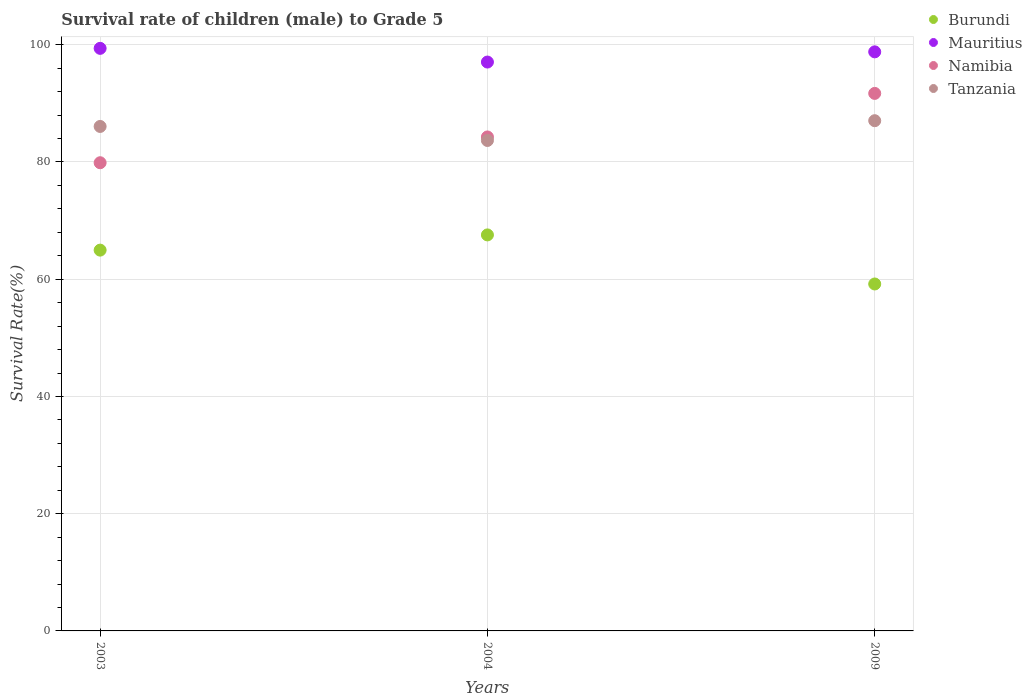How many different coloured dotlines are there?
Offer a terse response. 4. What is the survival rate of male children to grade 5 in Mauritius in 2004?
Provide a succinct answer. 97.05. Across all years, what is the maximum survival rate of male children to grade 5 in Namibia?
Your response must be concise. 91.7. Across all years, what is the minimum survival rate of male children to grade 5 in Mauritius?
Ensure brevity in your answer.  97.05. In which year was the survival rate of male children to grade 5 in Namibia minimum?
Offer a very short reply. 2003. What is the total survival rate of male children to grade 5 in Namibia in the graph?
Offer a very short reply. 255.85. What is the difference between the survival rate of male children to grade 5 in Mauritius in 2003 and that in 2009?
Offer a very short reply. 0.6. What is the difference between the survival rate of male children to grade 5 in Tanzania in 2003 and the survival rate of male children to grade 5 in Namibia in 2009?
Make the answer very short. -5.64. What is the average survival rate of male children to grade 5 in Mauritius per year?
Give a very brief answer. 98.41. In the year 2003, what is the difference between the survival rate of male children to grade 5 in Tanzania and survival rate of male children to grade 5 in Burundi?
Your answer should be very brief. 21.1. In how many years, is the survival rate of male children to grade 5 in Namibia greater than 28 %?
Provide a short and direct response. 3. What is the ratio of the survival rate of male children to grade 5 in Mauritius in 2004 to that in 2009?
Your answer should be compact. 0.98. Is the survival rate of male children to grade 5 in Burundi in 2004 less than that in 2009?
Your answer should be very brief. No. Is the difference between the survival rate of male children to grade 5 in Tanzania in 2003 and 2004 greater than the difference between the survival rate of male children to grade 5 in Burundi in 2003 and 2004?
Keep it short and to the point. Yes. What is the difference between the highest and the second highest survival rate of male children to grade 5 in Burundi?
Offer a terse response. 2.6. What is the difference between the highest and the lowest survival rate of male children to grade 5 in Mauritius?
Ensure brevity in your answer.  2.34. In how many years, is the survival rate of male children to grade 5 in Tanzania greater than the average survival rate of male children to grade 5 in Tanzania taken over all years?
Ensure brevity in your answer.  2. Does the survival rate of male children to grade 5 in Burundi monotonically increase over the years?
Your answer should be compact. No. Is the survival rate of male children to grade 5 in Mauritius strictly greater than the survival rate of male children to grade 5 in Tanzania over the years?
Provide a succinct answer. Yes. How many dotlines are there?
Provide a succinct answer. 4. How many years are there in the graph?
Give a very brief answer. 3. Are the values on the major ticks of Y-axis written in scientific E-notation?
Offer a very short reply. No. How many legend labels are there?
Your response must be concise. 4. What is the title of the graph?
Ensure brevity in your answer.  Survival rate of children (male) to Grade 5. What is the label or title of the Y-axis?
Offer a terse response. Survival Rate(%). What is the Survival Rate(%) in Burundi in 2003?
Provide a succinct answer. 64.96. What is the Survival Rate(%) of Mauritius in 2003?
Offer a very short reply. 99.39. What is the Survival Rate(%) of Namibia in 2003?
Keep it short and to the point. 79.87. What is the Survival Rate(%) in Tanzania in 2003?
Your answer should be very brief. 86.06. What is the Survival Rate(%) of Burundi in 2004?
Provide a succinct answer. 67.56. What is the Survival Rate(%) in Mauritius in 2004?
Your response must be concise. 97.05. What is the Survival Rate(%) of Namibia in 2004?
Ensure brevity in your answer.  84.27. What is the Survival Rate(%) in Tanzania in 2004?
Your answer should be very brief. 83.67. What is the Survival Rate(%) of Burundi in 2009?
Offer a terse response. 59.19. What is the Survival Rate(%) of Mauritius in 2009?
Your response must be concise. 98.79. What is the Survival Rate(%) in Namibia in 2009?
Your response must be concise. 91.7. What is the Survival Rate(%) of Tanzania in 2009?
Offer a terse response. 87.04. Across all years, what is the maximum Survival Rate(%) of Burundi?
Keep it short and to the point. 67.56. Across all years, what is the maximum Survival Rate(%) of Mauritius?
Provide a short and direct response. 99.39. Across all years, what is the maximum Survival Rate(%) in Namibia?
Your answer should be very brief. 91.7. Across all years, what is the maximum Survival Rate(%) in Tanzania?
Provide a succinct answer. 87.04. Across all years, what is the minimum Survival Rate(%) of Burundi?
Your answer should be compact. 59.19. Across all years, what is the minimum Survival Rate(%) of Mauritius?
Keep it short and to the point. 97.05. Across all years, what is the minimum Survival Rate(%) of Namibia?
Give a very brief answer. 79.87. Across all years, what is the minimum Survival Rate(%) of Tanzania?
Keep it short and to the point. 83.67. What is the total Survival Rate(%) of Burundi in the graph?
Offer a very short reply. 191.71. What is the total Survival Rate(%) of Mauritius in the graph?
Keep it short and to the point. 295.23. What is the total Survival Rate(%) in Namibia in the graph?
Your answer should be compact. 255.85. What is the total Survival Rate(%) of Tanzania in the graph?
Give a very brief answer. 256.78. What is the difference between the Survival Rate(%) in Burundi in 2003 and that in 2004?
Make the answer very short. -2.6. What is the difference between the Survival Rate(%) in Mauritius in 2003 and that in 2004?
Keep it short and to the point. 2.34. What is the difference between the Survival Rate(%) in Namibia in 2003 and that in 2004?
Provide a succinct answer. -4.4. What is the difference between the Survival Rate(%) of Tanzania in 2003 and that in 2004?
Give a very brief answer. 2.39. What is the difference between the Survival Rate(%) in Burundi in 2003 and that in 2009?
Your answer should be compact. 5.78. What is the difference between the Survival Rate(%) of Mauritius in 2003 and that in 2009?
Provide a succinct answer. 0.6. What is the difference between the Survival Rate(%) in Namibia in 2003 and that in 2009?
Your answer should be compact. -11.83. What is the difference between the Survival Rate(%) of Tanzania in 2003 and that in 2009?
Your answer should be compact. -0.98. What is the difference between the Survival Rate(%) in Burundi in 2004 and that in 2009?
Provide a succinct answer. 8.37. What is the difference between the Survival Rate(%) in Mauritius in 2004 and that in 2009?
Make the answer very short. -1.74. What is the difference between the Survival Rate(%) of Namibia in 2004 and that in 2009?
Provide a short and direct response. -7.43. What is the difference between the Survival Rate(%) of Tanzania in 2004 and that in 2009?
Provide a short and direct response. -3.37. What is the difference between the Survival Rate(%) in Burundi in 2003 and the Survival Rate(%) in Mauritius in 2004?
Make the answer very short. -32.09. What is the difference between the Survival Rate(%) in Burundi in 2003 and the Survival Rate(%) in Namibia in 2004?
Provide a short and direct response. -19.31. What is the difference between the Survival Rate(%) of Burundi in 2003 and the Survival Rate(%) of Tanzania in 2004?
Provide a short and direct response. -18.71. What is the difference between the Survival Rate(%) of Mauritius in 2003 and the Survival Rate(%) of Namibia in 2004?
Make the answer very short. 15.11. What is the difference between the Survival Rate(%) of Mauritius in 2003 and the Survival Rate(%) of Tanzania in 2004?
Provide a short and direct response. 15.72. What is the difference between the Survival Rate(%) of Namibia in 2003 and the Survival Rate(%) of Tanzania in 2004?
Provide a succinct answer. -3.8. What is the difference between the Survival Rate(%) in Burundi in 2003 and the Survival Rate(%) in Mauritius in 2009?
Ensure brevity in your answer.  -33.83. What is the difference between the Survival Rate(%) of Burundi in 2003 and the Survival Rate(%) of Namibia in 2009?
Give a very brief answer. -26.74. What is the difference between the Survival Rate(%) of Burundi in 2003 and the Survival Rate(%) of Tanzania in 2009?
Ensure brevity in your answer.  -22.08. What is the difference between the Survival Rate(%) in Mauritius in 2003 and the Survival Rate(%) in Namibia in 2009?
Give a very brief answer. 7.69. What is the difference between the Survival Rate(%) in Mauritius in 2003 and the Survival Rate(%) in Tanzania in 2009?
Provide a short and direct response. 12.34. What is the difference between the Survival Rate(%) of Namibia in 2003 and the Survival Rate(%) of Tanzania in 2009?
Your answer should be compact. -7.17. What is the difference between the Survival Rate(%) in Burundi in 2004 and the Survival Rate(%) in Mauritius in 2009?
Offer a terse response. -31.23. What is the difference between the Survival Rate(%) of Burundi in 2004 and the Survival Rate(%) of Namibia in 2009?
Make the answer very short. -24.14. What is the difference between the Survival Rate(%) in Burundi in 2004 and the Survival Rate(%) in Tanzania in 2009?
Offer a terse response. -19.48. What is the difference between the Survival Rate(%) in Mauritius in 2004 and the Survival Rate(%) in Namibia in 2009?
Offer a terse response. 5.35. What is the difference between the Survival Rate(%) in Mauritius in 2004 and the Survival Rate(%) in Tanzania in 2009?
Provide a short and direct response. 10.01. What is the difference between the Survival Rate(%) in Namibia in 2004 and the Survival Rate(%) in Tanzania in 2009?
Offer a terse response. -2.77. What is the average Survival Rate(%) of Burundi per year?
Ensure brevity in your answer.  63.9. What is the average Survival Rate(%) in Mauritius per year?
Make the answer very short. 98.41. What is the average Survival Rate(%) of Namibia per year?
Your answer should be compact. 85.28. What is the average Survival Rate(%) of Tanzania per year?
Ensure brevity in your answer.  85.59. In the year 2003, what is the difference between the Survival Rate(%) of Burundi and Survival Rate(%) of Mauritius?
Provide a short and direct response. -34.42. In the year 2003, what is the difference between the Survival Rate(%) of Burundi and Survival Rate(%) of Namibia?
Your answer should be very brief. -14.91. In the year 2003, what is the difference between the Survival Rate(%) in Burundi and Survival Rate(%) in Tanzania?
Your answer should be compact. -21.1. In the year 2003, what is the difference between the Survival Rate(%) in Mauritius and Survival Rate(%) in Namibia?
Provide a short and direct response. 19.51. In the year 2003, what is the difference between the Survival Rate(%) of Mauritius and Survival Rate(%) of Tanzania?
Ensure brevity in your answer.  13.32. In the year 2003, what is the difference between the Survival Rate(%) in Namibia and Survival Rate(%) in Tanzania?
Offer a very short reply. -6.19. In the year 2004, what is the difference between the Survival Rate(%) of Burundi and Survival Rate(%) of Mauritius?
Your response must be concise. -29.49. In the year 2004, what is the difference between the Survival Rate(%) in Burundi and Survival Rate(%) in Namibia?
Make the answer very short. -16.71. In the year 2004, what is the difference between the Survival Rate(%) in Burundi and Survival Rate(%) in Tanzania?
Offer a very short reply. -16.11. In the year 2004, what is the difference between the Survival Rate(%) of Mauritius and Survival Rate(%) of Namibia?
Your answer should be very brief. 12.78. In the year 2004, what is the difference between the Survival Rate(%) of Mauritius and Survival Rate(%) of Tanzania?
Your response must be concise. 13.38. In the year 2004, what is the difference between the Survival Rate(%) in Namibia and Survival Rate(%) in Tanzania?
Give a very brief answer. 0.6. In the year 2009, what is the difference between the Survival Rate(%) in Burundi and Survival Rate(%) in Mauritius?
Offer a very short reply. -39.6. In the year 2009, what is the difference between the Survival Rate(%) of Burundi and Survival Rate(%) of Namibia?
Offer a very short reply. -32.51. In the year 2009, what is the difference between the Survival Rate(%) in Burundi and Survival Rate(%) in Tanzania?
Your response must be concise. -27.86. In the year 2009, what is the difference between the Survival Rate(%) of Mauritius and Survival Rate(%) of Namibia?
Your response must be concise. 7.09. In the year 2009, what is the difference between the Survival Rate(%) of Mauritius and Survival Rate(%) of Tanzania?
Offer a terse response. 11.75. In the year 2009, what is the difference between the Survival Rate(%) of Namibia and Survival Rate(%) of Tanzania?
Offer a terse response. 4.66. What is the ratio of the Survival Rate(%) of Burundi in 2003 to that in 2004?
Keep it short and to the point. 0.96. What is the ratio of the Survival Rate(%) of Mauritius in 2003 to that in 2004?
Your answer should be very brief. 1.02. What is the ratio of the Survival Rate(%) of Namibia in 2003 to that in 2004?
Provide a short and direct response. 0.95. What is the ratio of the Survival Rate(%) of Tanzania in 2003 to that in 2004?
Offer a terse response. 1.03. What is the ratio of the Survival Rate(%) in Burundi in 2003 to that in 2009?
Provide a succinct answer. 1.1. What is the ratio of the Survival Rate(%) of Mauritius in 2003 to that in 2009?
Offer a terse response. 1.01. What is the ratio of the Survival Rate(%) of Namibia in 2003 to that in 2009?
Provide a succinct answer. 0.87. What is the ratio of the Survival Rate(%) of Tanzania in 2003 to that in 2009?
Ensure brevity in your answer.  0.99. What is the ratio of the Survival Rate(%) in Burundi in 2004 to that in 2009?
Your answer should be compact. 1.14. What is the ratio of the Survival Rate(%) of Mauritius in 2004 to that in 2009?
Your answer should be very brief. 0.98. What is the ratio of the Survival Rate(%) of Namibia in 2004 to that in 2009?
Offer a very short reply. 0.92. What is the ratio of the Survival Rate(%) in Tanzania in 2004 to that in 2009?
Keep it short and to the point. 0.96. What is the difference between the highest and the second highest Survival Rate(%) of Burundi?
Make the answer very short. 2.6. What is the difference between the highest and the second highest Survival Rate(%) of Mauritius?
Your answer should be compact. 0.6. What is the difference between the highest and the second highest Survival Rate(%) in Namibia?
Your answer should be compact. 7.43. What is the difference between the highest and the lowest Survival Rate(%) in Burundi?
Keep it short and to the point. 8.37. What is the difference between the highest and the lowest Survival Rate(%) in Mauritius?
Give a very brief answer. 2.34. What is the difference between the highest and the lowest Survival Rate(%) of Namibia?
Ensure brevity in your answer.  11.83. What is the difference between the highest and the lowest Survival Rate(%) in Tanzania?
Offer a very short reply. 3.37. 